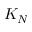Convert formula to latex. <formula><loc_0><loc_0><loc_500><loc_500>K _ { N }</formula> 